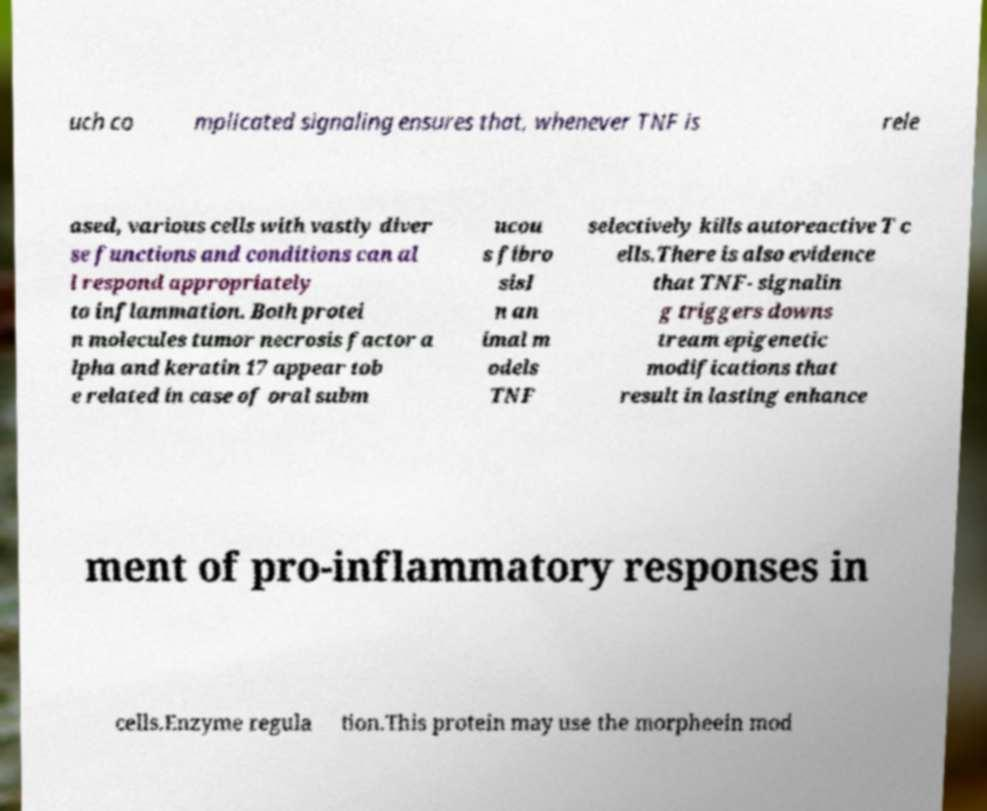Please read and relay the text visible in this image. What does it say? uch co mplicated signaling ensures that, whenever TNF is rele ased, various cells with vastly diver se functions and conditions can al l respond appropriately to inflammation. Both protei n molecules tumor necrosis factor a lpha and keratin 17 appear tob e related in case of oral subm ucou s fibro sisI n an imal m odels TNF selectively kills autoreactive T c ells.There is also evidence that TNF- signalin g triggers downs tream epigenetic modifications that result in lasting enhance ment of pro-inflammatory responses in cells.Enzyme regula tion.This protein may use the morpheein mod 